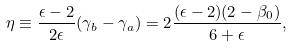<formula> <loc_0><loc_0><loc_500><loc_500>\eta \equiv \frac { \epsilon - 2 } { 2 \epsilon } ( \gamma _ { b } - \gamma _ { a } ) = 2 \frac { ( \epsilon - 2 ) ( 2 - \beta _ { 0 } ) } { 6 + \epsilon } ,</formula> 